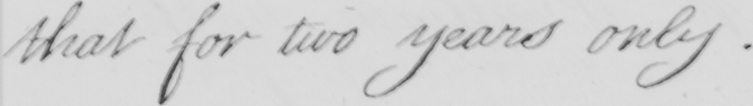Can you tell me what this handwritten text says? that for two years only. 